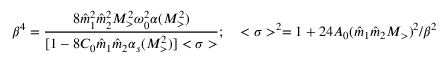<formula> <loc_0><loc_0><loc_500><loc_500>\beta ^ { 4 } = { \frac { 8 { \hat { m } } _ { 1 } ^ { 2 } { \hat { m } } _ { 2 } ^ { 2 } M _ { > } ^ { 2 } \omega _ { 0 } ^ { 2 } \alpha ( M _ { > } ^ { 2 } ) } { [ 1 - 8 C _ { 0 } { \hat { m } } _ { 1 } { \hat { m } } _ { 2 } \alpha _ { s } ( M _ { > } ^ { 2 } ) ] < \sigma > } } ; \quad < \sigma > ^ { 2 } = 1 + 2 4 A _ { 0 } ( { \hat { m } } _ { 1 } { \hat { m } } _ { 2 } M _ { > } ) ^ { 2 } / \beta ^ { 2 }</formula> 